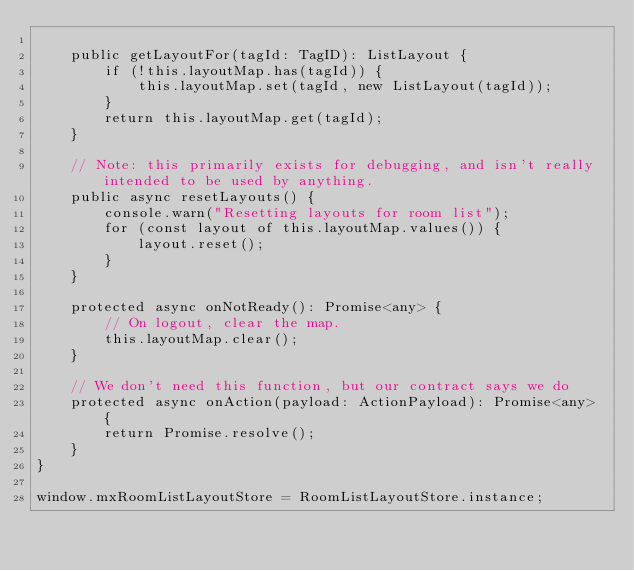Convert code to text. <code><loc_0><loc_0><loc_500><loc_500><_TypeScript_>
    public getLayoutFor(tagId: TagID): ListLayout {
        if (!this.layoutMap.has(tagId)) {
            this.layoutMap.set(tagId, new ListLayout(tagId));
        }
        return this.layoutMap.get(tagId);
    }

    // Note: this primarily exists for debugging, and isn't really intended to be used by anything.
    public async resetLayouts() {
        console.warn("Resetting layouts for room list");
        for (const layout of this.layoutMap.values()) {
            layout.reset();
        }
    }

    protected async onNotReady(): Promise<any> {
        // On logout, clear the map.
        this.layoutMap.clear();
    }

    // We don't need this function, but our contract says we do
    protected async onAction(payload: ActionPayload): Promise<any> {
        return Promise.resolve();
    }
}

window.mxRoomListLayoutStore = RoomListLayoutStore.instance;
</code> 